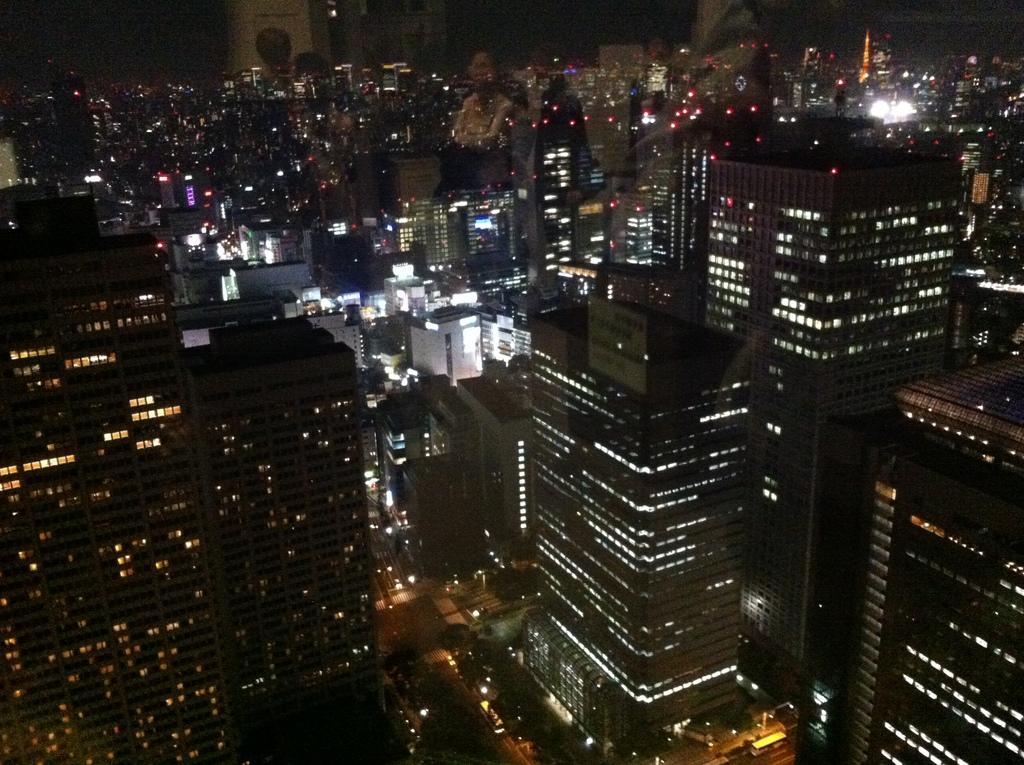Can you describe this image briefly? This is a glass. Through the glass we can see many buildings, lights, trees, road and sky. On the glass we can see the reflections of few persons. 